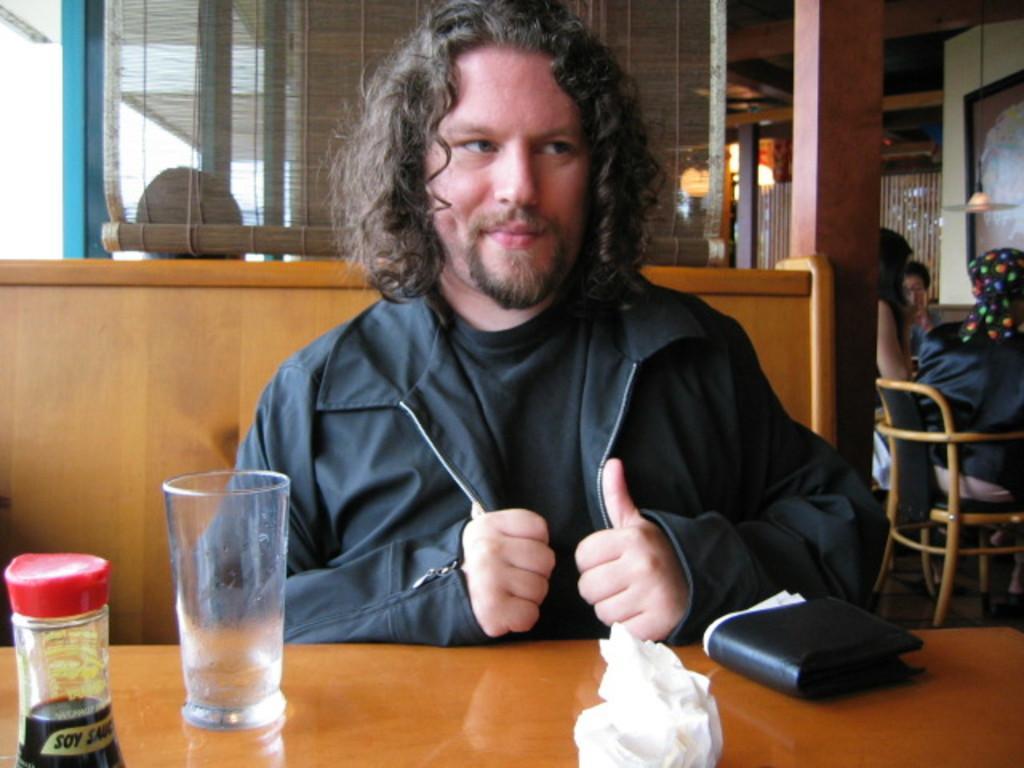How would you summarize this image in a sentence or two? In this image we can see a person sitting in the middle on a chair, in front with him there is a table, on top of that we can see a bottle, glass, tissue paper, and wallet, behind the person, there are few other persons sitting on the chairs, there is a hanging light, curtain, pillars and a wall. 